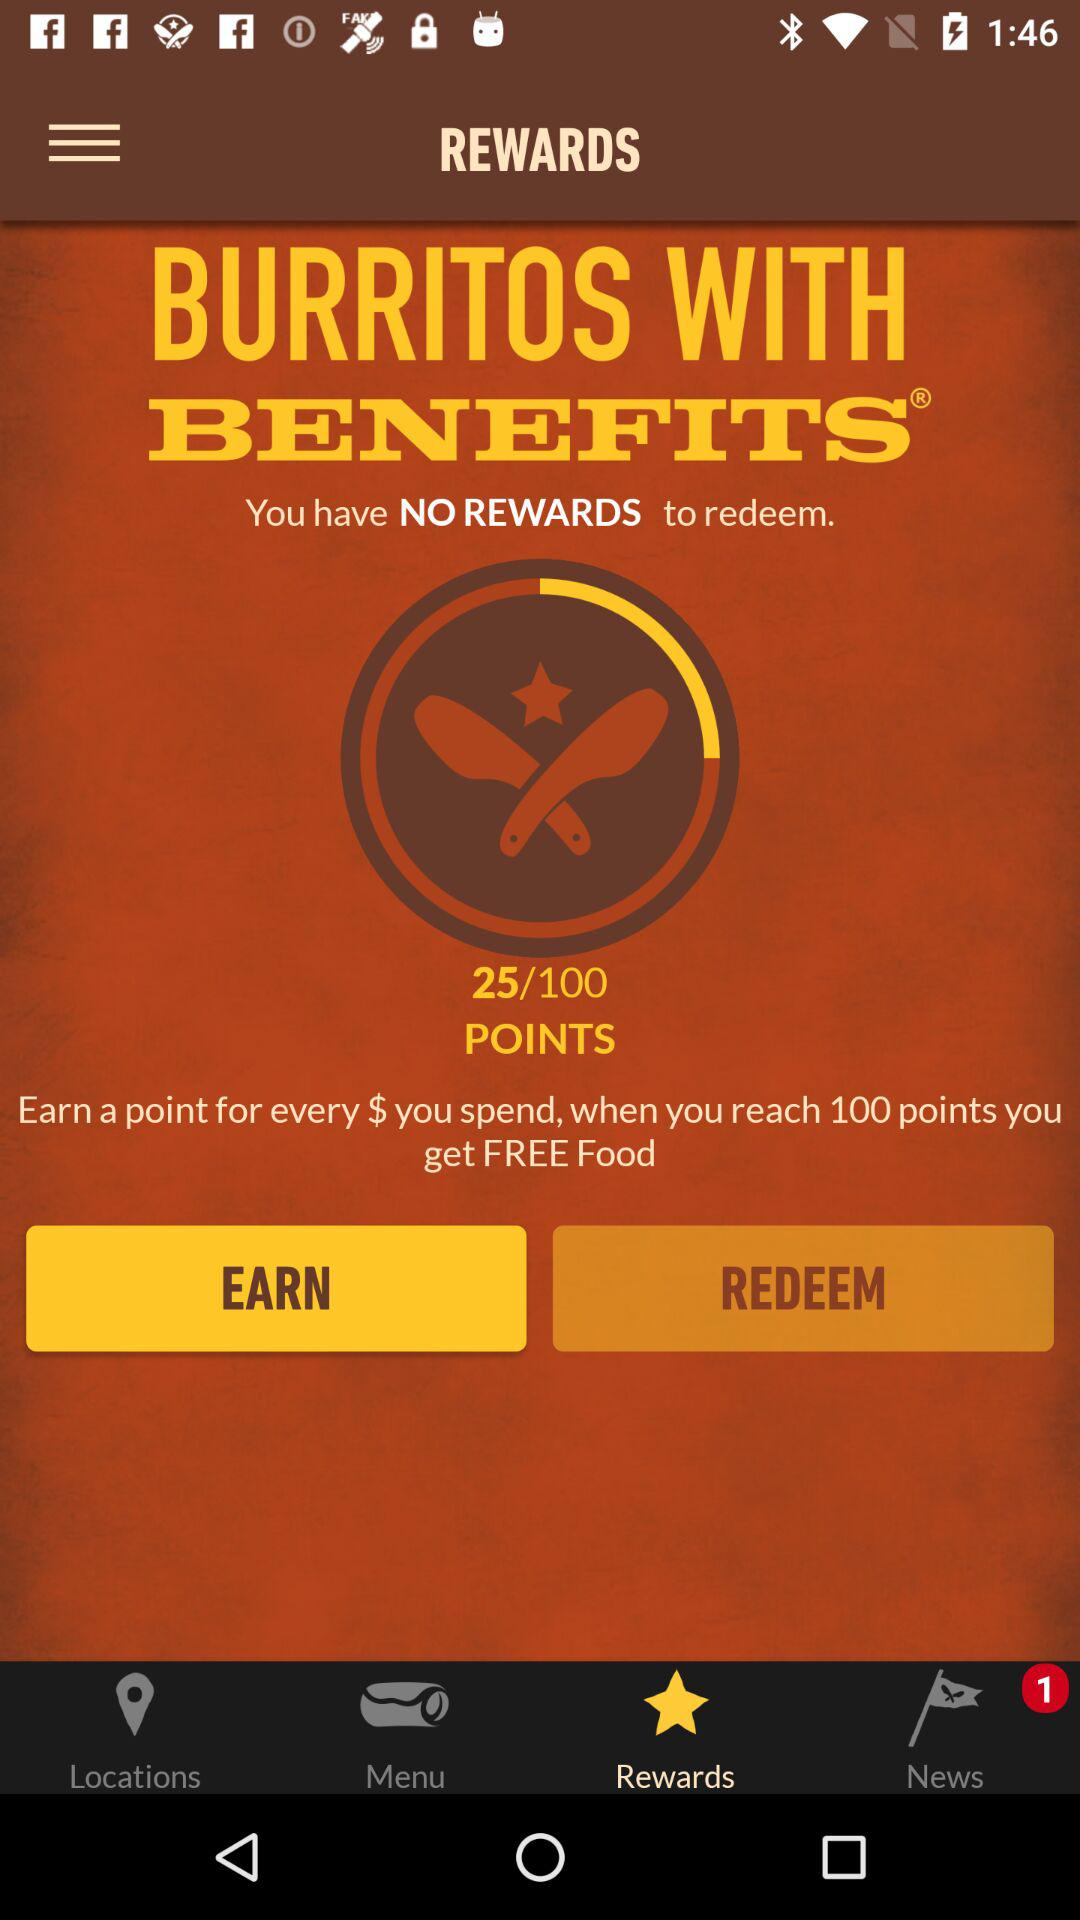Are there any rewards to redeem? There are no rewards to redeem. 